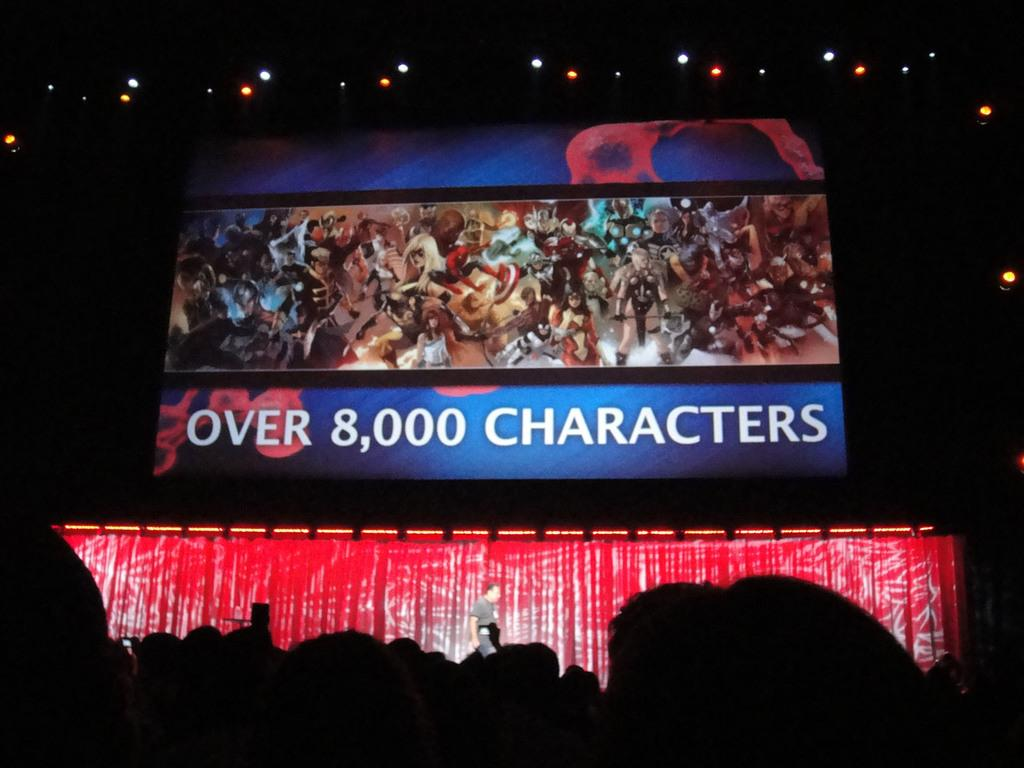What is the man in the image doing? The man is standing on a stage. What is located behind the man on the stage? There is a screen behind the man. What can be seen in the image that might be used for illumination? There are lights visible in the image. How would you describe the overall lighting in the image? The background of the image is dark. What type of songs is the man playing on his instrument in the image? There is no instrument present in the image, and the man is not playing any songs. 